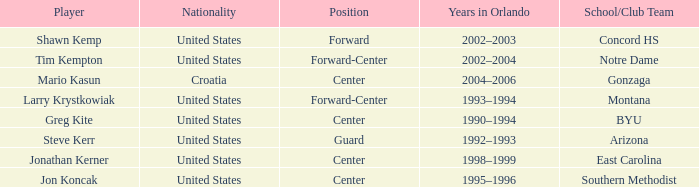What years in Orlando have the United States as the nationality, with concord hs as the school/club team? 2002–2003. 